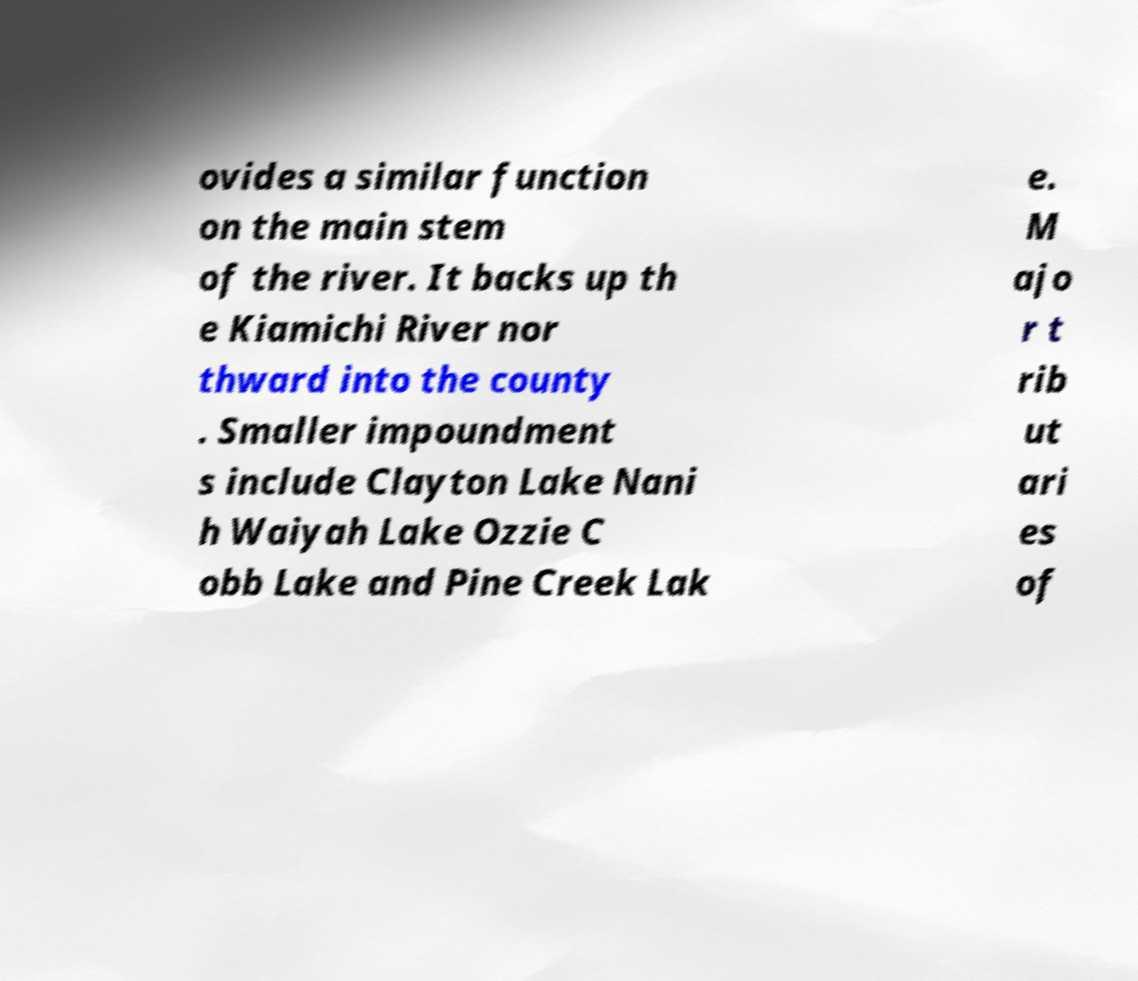Can you read and provide the text displayed in the image?This photo seems to have some interesting text. Can you extract and type it out for me? ovides a similar function on the main stem of the river. It backs up th e Kiamichi River nor thward into the county . Smaller impoundment s include Clayton Lake Nani h Waiyah Lake Ozzie C obb Lake and Pine Creek Lak e. M ajo r t rib ut ari es of 